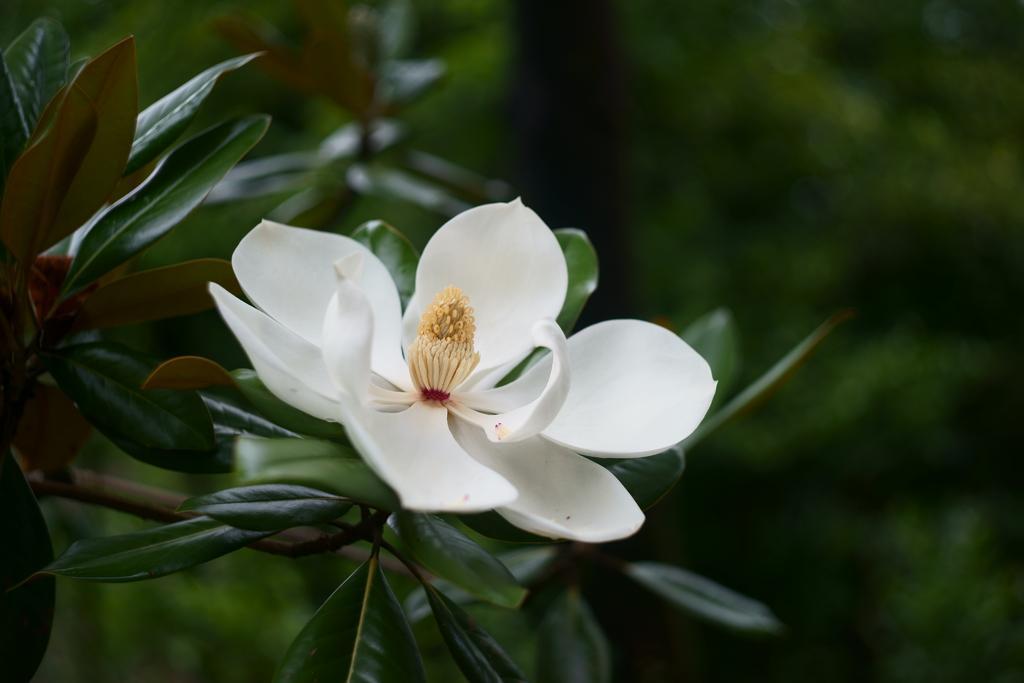In one or two sentences, can you explain what this image depicts? In this image there is a white flower in the middle. In the flower there is a stigma and pollen grains around it. In the background there are green leaves. 